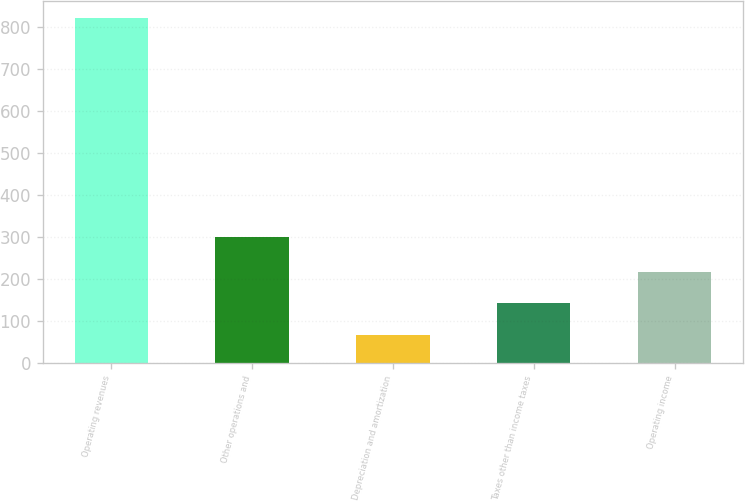<chart> <loc_0><loc_0><loc_500><loc_500><bar_chart><fcel>Operating revenues<fcel>Other operations and<fcel>Depreciation and amortization<fcel>Taxes other than income taxes<fcel>Operating income<nl><fcel>821<fcel>301<fcel>67<fcel>142.4<fcel>217.8<nl></chart> 